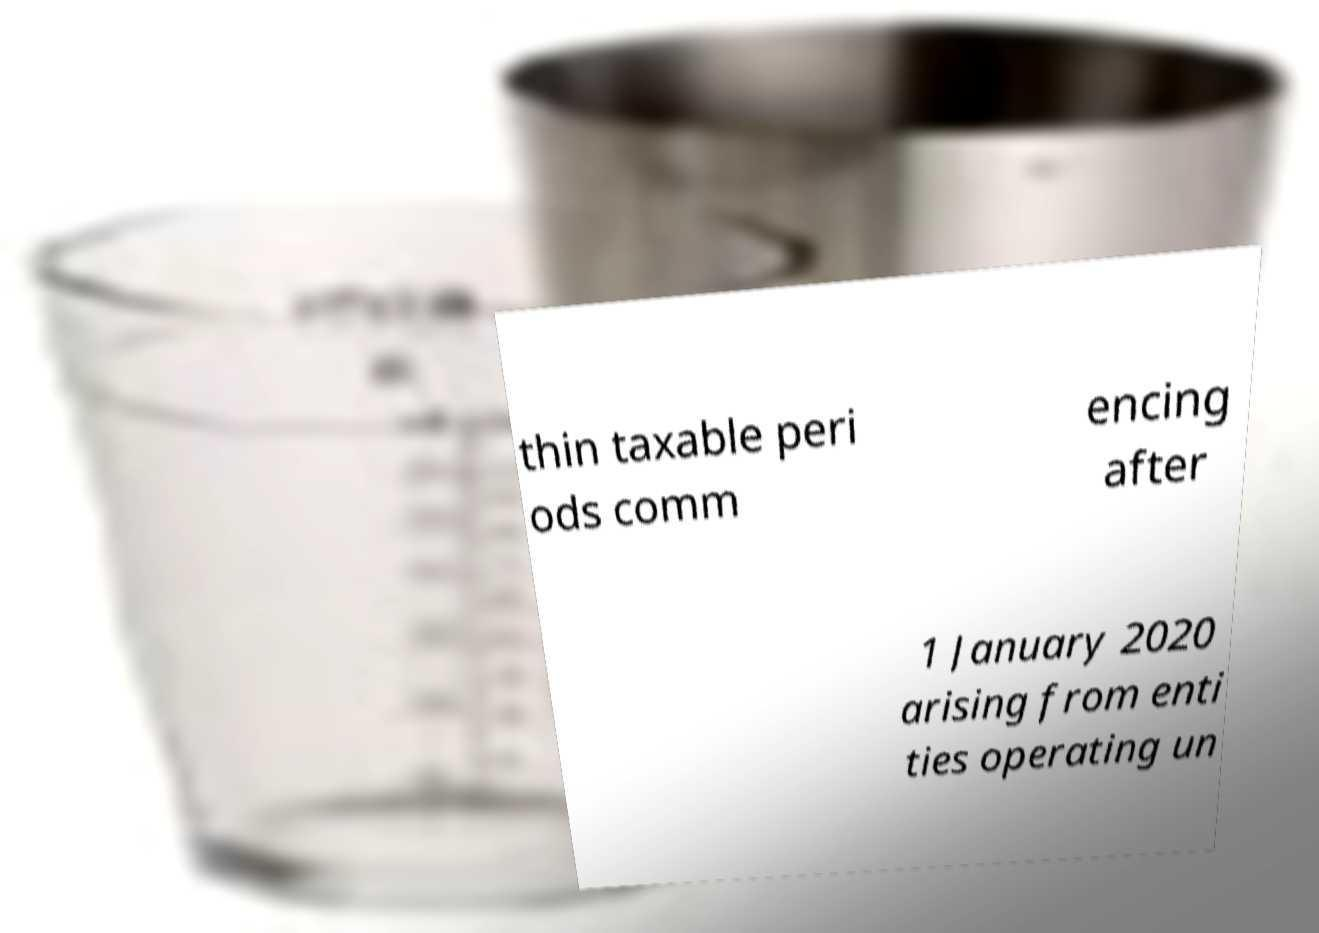Could you extract and type out the text from this image? thin taxable peri ods comm encing after 1 January 2020 arising from enti ties operating un 